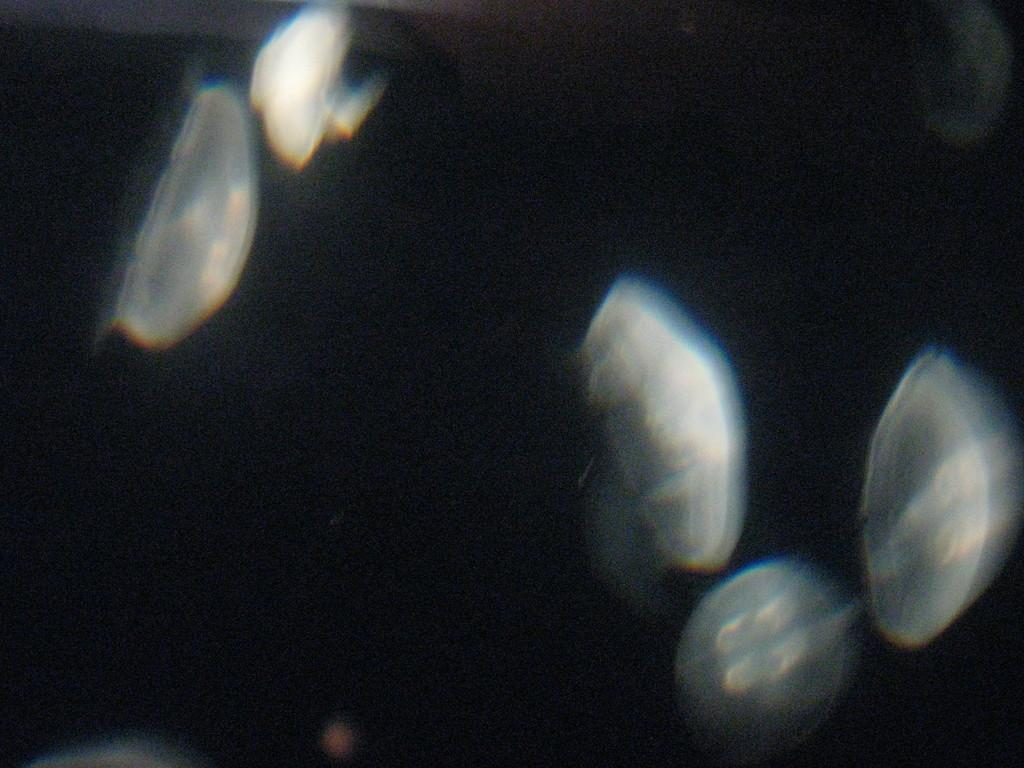What is the color of the background in the image? The background of the image is dark. Can you describe any objects that are visible in the image? There are objects visible in the image, but their specific details cannot be determined from the provided facts. What type of home can be seen in the image? There is no home visible in the image; only the dark background and objects can be observed. What songs are being played in the background of the image? There is no information about songs being played in the image, as the focus is on the dark background and objects. 